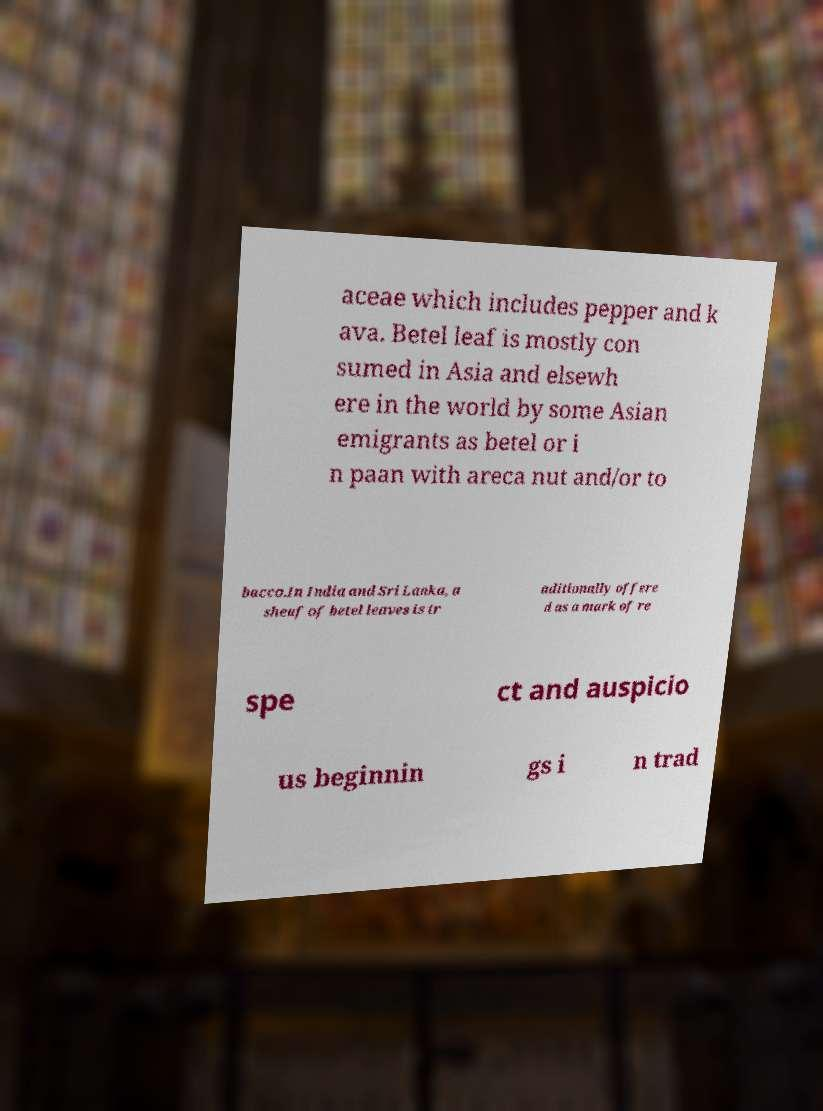Can you read and provide the text displayed in the image?This photo seems to have some interesting text. Can you extract and type it out for me? aceae which includes pepper and k ava. Betel leaf is mostly con sumed in Asia and elsewh ere in the world by some Asian emigrants as betel or i n paan with areca nut and/or to bacco.In India and Sri Lanka, a sheaf of betel leaves is tr aditionally offere d as a mark of re spe ct and auspicio us beginnin gs i n trad 